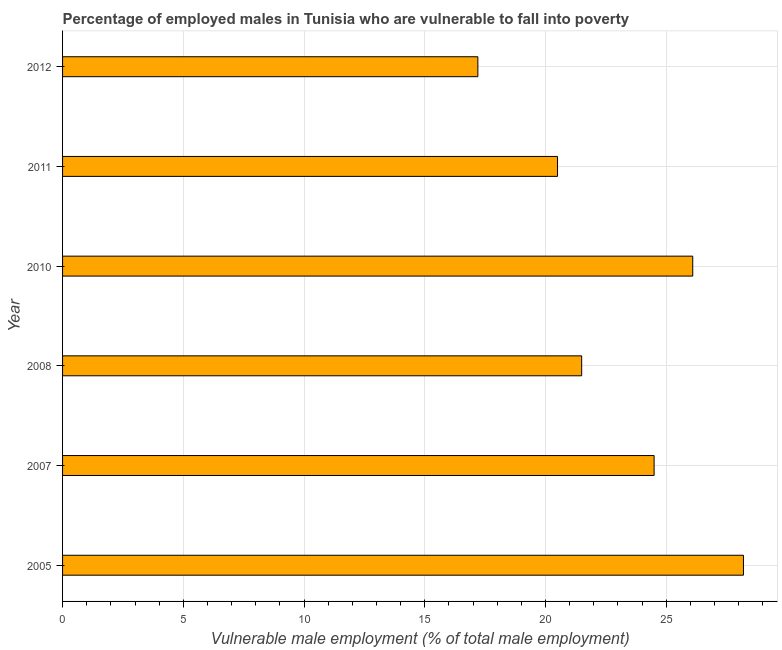Does the graph contain any zero values?
Provide a short and direct response. No. Does the graph contain grids?
Offer a terse response. Yes. What is the title of the graph?
Provide a short and direct response. Percentage of employed males in Tunisia who are vulnerable to fall into poverty. What is the label or title of the X-axis?
Your response must be concise. Vulnerable male employment (% of total male employment). What is the percentage of employed males who are vulnerable to fall into poverty in 2012?
Offer a terse response. 17.2. Across all years, what is the maximum percentage of employed males who are vulnerable to fall into poverty?
Provide a succinct answer. 28.2. Across all years, what is the minimum percentage of employed males who are vulnerable to fall into poverty?
Ensure brevity in your answer.  17.2. In which year was the percentage of employed males who are vulnerable to fall into poverty maximum?
Offer a very short reply. 2005. In which year was the percentage of employed males who are vulnerable to fall into poverty minimum?
Offer a very short reply. 2012. What is the sum of the percentage of employed males who are vulnerable to fall into poverty?
Ensure brevity in your answer.  138. What is the ratio of the percentage of employed males who are vulnerable to fall into poverty in 2007 to that in 2008?
Your answer should be compact. 1.14. What is the difference between the highest and the second highest percentage of employed males who are vulnerable to fall into poverty?
Provide a succinct answer. 2.1. Is the sum of the percentage of employed males who are vulnerable to fall into poverty in 2010 and 2011 greater than the maximum percentage of employed males who are vulnerable to fall into poverty across all years?
Your answer should be compact. Yes. How many bars are there?
Ensure brevity in your answer.  6. What is the Vulnerable male employment (% of total male employment) in 2005?
Your response must be concise. 28.2. What is the Vulnerable male employment (% of total male employment) in 2007?
Your answer should be very brief. 24.5. What is the Vulnerable male employment (% of total male employment) of 2008?
Ensure brevity in your answer.  21.5. What is the Vulnerable male employment (% of total male employment) of 2010?
Provide a short and direct response. 26.1. What is the Vulnerable male employment (% of total male employment) of 2012?
Provide a short and direct response. 17.2. What is the difference between the Vulnerable male employment (% of total male employment) in 2005 and 2007?
Provide a short and direct response. 3.7. What is the difference between the Vulnerable male employment (% of total male employment) in 2005 and 2010?
Provide a short and direct response. 2.1. What is the difference between the Vulnerable male employment (% of total male employment) in 2005 and 2011?
Your answer should be compact. 7.7. What is the difference between the Vulnerable male employment (% of total male employment) in 2005 and 2012?
Your response must be concise. 11. What is the difference between the Vulnerable male employment (% of total male employment) in 2007 and 2010?
Provide a succinct answer. -1.6. What is the difference between the Vulnerable male employment (% of total male employment) in 2007 and 2011?
Your answer should be compact. 4. What is the difference between the Vulnerable male employment (% of total male employment) in 2008 and 2011?
Keep it short and to the point. 1. What is the difference between the Vulnerable male employment (% of total male employment) in 2010 and 2011?
Ensure brevity in your answer.  5.6. What is the difference between the Vulnerable male employment (% of total male employment) in 2010 and 2012?
Offer a very short reply. 8.9. What is the difference between the Vulnerable male employment (% of total male employment) in 2011 and 2012?
Give a very brief answer. 3.3. What is the ratio of the Vulnerable male employment (% of total male employment) in 2005 to that in 2007?
Ensure brevity in your answer.  1.15. What is the ratio of the Vulnerable male employment (% of total male employment) in 2005 to that in 2008?
Your answer should be very brief. 1.31. What is the ratio of the Vulnerable male employment (% of total male employment) in 2005 to that in 2011?
Make the answer very short. 1.38. What is the ratio of the Vulnerable male employment (% of total male employment) in 2005 to that in 2012?
Make the answer very short. 1.64. What is the ratio of the Vulnerable male employment (% of total male employment) in 2007 to that in 2008?
Your answer should be compact. 1.14. What is the ratio of the Vulnerable male employment (% of total male employment) in 2007 to that in 2010?
Offer a very short reply. 0.94. What is the ratio of the Vulnerable male employment (% of total male employment) in 2007 to that in 2011?
Make the answer very short. 1.2. What is the ratio of the Vulnerable male employment (% of total male employment) in 2007 to that in 2012?
Provide a succinct answer. 1.42. What is the ratio of the Vulnerable male employment (% of total male employment) in 2008 to that in 2010?
Ensure brevity in your answer.  0.82. What is the ratio of the Vulnerable male employment (% of total male employment) in 2008 to that in 2011?
Offer a very short reply. 1.05. What is the ratio of the Vulnerable male employment (% of total male employment) in 2008 to that in 2012?
Give a very brief answer. 1.25. What is the ratio of the Vulnerable male employment (% of total male employment) in 2010 to that in 2011?
Your response must be concise. 1.27. What is the ratio of the Vulnerable male employment (% of total male employment) in 2010 to that in 2012?
Make the answer very short. 1.52. What is the ratio of the Vulnerable male employment (% of total male employment) in 2011 to that in 2012?
Your answer should be very brief. 1.19. 